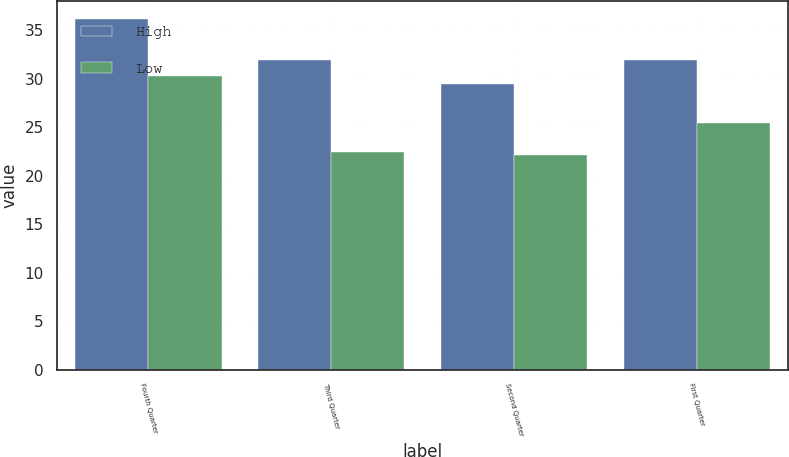Convert chart to OTSL. <chart><loc_0><loc_0><loc_500><loc_500><stacked_bar_chart><ecel><fcel>Fourth Quarter<fcel>Third Quarter<fcel>Second Quarter<fcel>First Quarter<nl><fcel>High<fcel>36.18<fcel>31.97<fcel>29.45<fcel>31.96<nl><fcel>Low<fcel>30.26<fcel>22.45<fcel>22.12<fcel>25.4<nl></chart> 